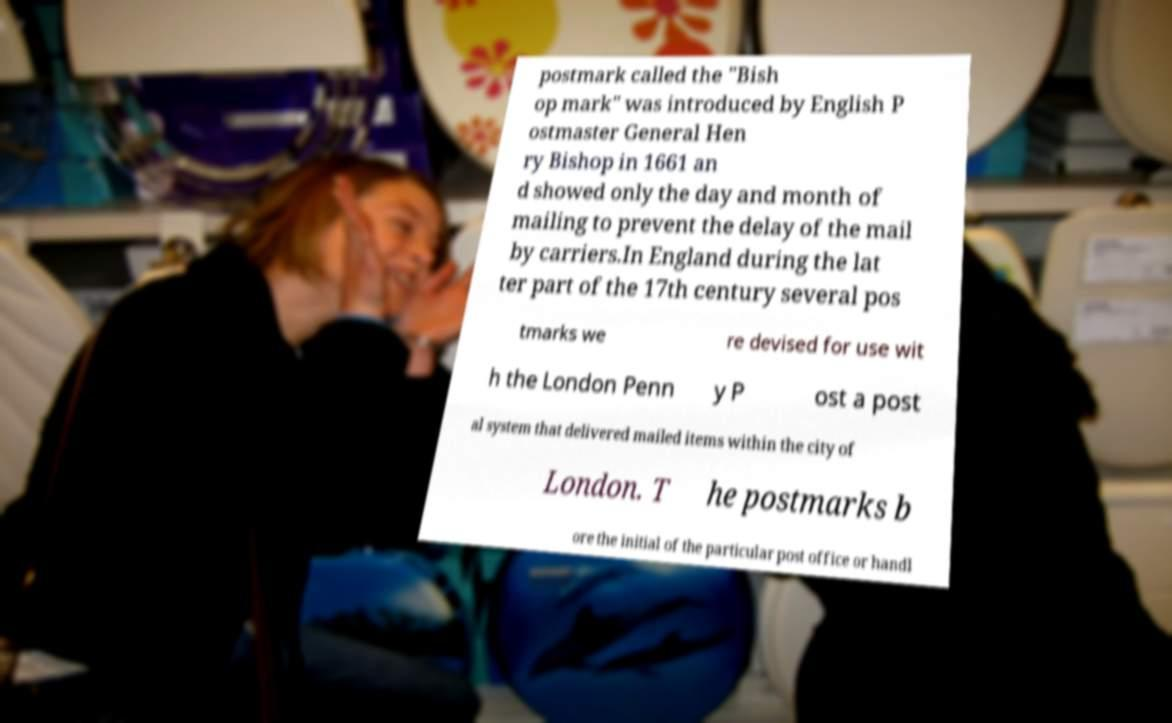I need the written content from this picture converted into text. Can you do that? postmark called the "Bish op mark" was introduced by English P ostmaster General Hen ry Bishop in 1661 an d showed only the day and month of mailing to prevent the delay of the mail by carriers.In England during the lat ter part of the 17th century several pos tmarks we re devised for use wit h the London Penn y P ost a post al system that delivered mailed items within the city of London. T he postmarks b ore the initial of the particular post office or handl 